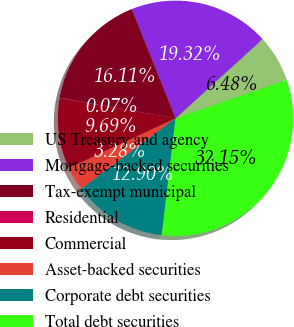<chart> <loc_0><loc_0><loc_500><loc_500><pie_chart><fcel>US Treasury and agency<fcel>Mortgage-backed securities<fcel>Tax-exempt municipal<fcel>Residential<fcel>Commercial<fcel>Asset-backed securities<fcel>Corporate debt securities<fcel>Total debt securities<nl><fcel>6.48%<fcel>19.32%<fcel>16.11%<fcel>0.07%<fcel>9.69%<fcel>3.28%<fcel>12.9%<fcel>32.15%<nl></chart> 